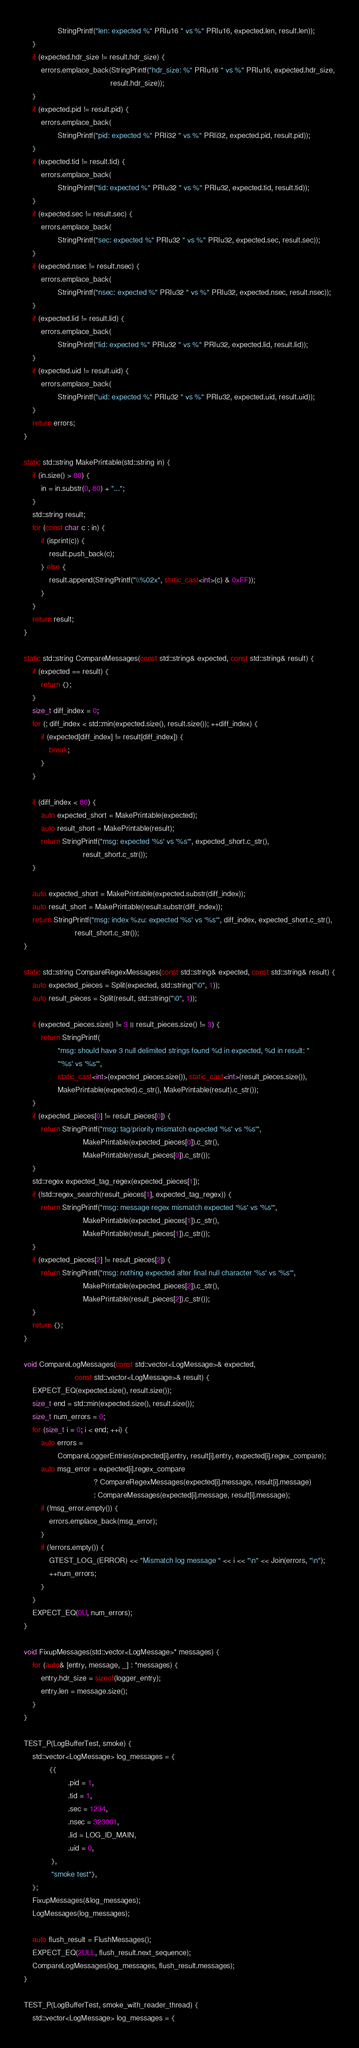<code> <loc_0><loc_0><loc_500><loc_500><_C++_>                StringPrintf("len: expected %" PRIu16 " vs %" PRIu16, expected.len, result.len));
    }
    if (expected.hdr_size != result.hdr_size) {
        errors.emplace_back(StringPrintf("hdr_size: %" PRIu16 " vs %" PRIu16, expected.hdr_size,
                                         result.hdr_size));
    }
    if (expected.pid != result.pid) {
        errors.emplace_back(
                StringPrintf("pid: expected %" PRIi32 " vs %" PRIi32, expected.pid, result.pid));
    }
    if (expected.tid != result.tid) {
        errors.emplace_back(
                StringPrintf("tid: expected %" PRIu32 " vs %" PRIu32, expected.tid, result.tid));
    }
    if (expected.sec != result.sec) {
        errors.emplace_back(
                StringPrintf("sec: expected %" PRIu32 " vs %" PRIu32, expected.sec, result.sec));
    }
    if (expected.nsec != result.nsec) {
        errors.emplace_back(
                StringPrintf("nsec: expected %" PRIu32 " vs %" PRIu32, expected.nsec, result.nsec));
    }
    if (expected.lid != result.lid) {
        errors.emplace_back(
                StringPrintf("lid: expected %" PRIu32 " vs %" PRIu32, expected.lid, result.lid));
    }
    if (expected.uid != result.uid) {
        errors.emplace_back(
                StringPrintf("uid: expected %" PRIu32 " vs %" PRIu32, expected.uid, result.uid));
    }
    return errors;
}

static std::string MakePrintable(std::string in) {
    if (in.size() > 80) {
        in = in.substr(0, 80) + "...";
    }
    std::string result;
    for (const char c : in) {
        if (isprint(c)) {
            result.push_back(c);
        } else {
            result.append(StringPrintf("\\%02x", static_cast<int>(c) & 0xFF));
        }
    }
    return result;
}

static std::string CompareMessages(const std::string& expected, const std::string& result) {
    if (expected == result) {
        return {};
    }
    size_t diff_index = 0;
    for (; diff_index < std::min(expected.size(), result.size()); ++diff_index) {
        if (expected[diff_index] != result[diff_index]) {
            break;
        }
    }

    if (diff_index < 80) {
        auto expected_short = MakePrintable(expected);
        auto result_short = MakePrintable(result);
        return StringPrintf("msg: expected '%s' vs '%s'", expected_short.c_str(),
                            result_short.c_str());
    }

    auto expected_short = MakePrintable(expected.substr(diff_index));
    auto result_short = MakePrintable(result.substr(diff_index));
    return StringPrintf("msg: index %zu: expected '%s' vs '%s'", diff_index, expected_short.c_str(),
                        result_short.c_str());
}

static std::string CompareRegexMessages(const std::string& expected, const std::string& result) {
    auto expected_pieces = Split(expected, std::string("\0", 1));
    auto result_pieces = Split(result, std::string("\0", 1));

    if (expected_pieces.size() != 3 || result_pieces.size() != 3) {
        return StringPrintf(
                "msg: should have 3 null delimited strings found %d in expected, %d in result: "
                "'%s' vs '%s'",
                static_cast<int>(expected_pieces.size()), static_cast<int>(result_pieces.size()),
                MakePrintable(expected).c_str(), MakePrintable(result).c_str());
    }
    if (expected_pieces[0] != result_pieces[0]) {
        return StringPrintf("msg: tag/priority mismatch expected '%s' vs '%s'",
                            MakePrintable(expected_pieces[0]).c_str(),
                            MakePrintable(result_pieces[0]).c_str());
    }
    std::regex expected_tag_regex(expected_pieces[1]);
    if (!std::regex_search(result_pieces[1], expected_tag_regex)) {
        return StringPrintf("msg: message regex mismatch expected '%s' vs '%s'",
                            MakePrintable(expected_pieces[1]).c_str(),
                            MakePrintable(result_pieces[1]).c_str());
    }
    if (expected_pieces[2] != result_pieces[2]) {
        return StringPrintf("msg: nothing expected after final null character '%s' vs '%s'",
                            MakePrintable(expected_pieces[2]).c_str(),
                            MakePrintable(result_pieces[2]).c_str());
    }
    return {};
}

void CompareLogMessages(const std::vector<LogMessage>& expected,
                        const std::vector<LogMessage>& result) {
    EXPECT_EQ(expected.size(), result.size());
    size_t end = std::min(expected.size(), result.size());
    size_t num_errors = 0;
    for (size_t i = 0; i < end; ++i) {
        auto errors =
                CompareLoggerEntries(expected[i].entry, result[i].entry, expected[i].regex_compare);
        auto msg_error = expected[i].regex_compare
                                 ? CompareRegexMessages(expected[i].message, result[i].message)
                                 : CompareMessages(expected[i].message, result[i].message);
        if (!msg_error.empty()) {
            errors.emplace_back(msg_error);
        }
        if (!errors.empty()) {
            GTEST_LOG_(ERROR) << "Mismatch log message " << i << "\n" << Join(errors, "\n");
            ++num_errors;
        }
    }
    EXPECT_EQ(0U, num_errors);
}

void FixupMessages(std::vector<LogMessage>* messages) {
    for (auto& [entry, message, _] : *messages) {
        entry.hdr_size = sizeof(logger_entry);
        entry.len = message.size();
    }
}

TEST_P(LogBufferTest, smoke) {
    std::vector<LogMessage> log_messages = {
            {{
                     .pid = 1,
                     .tid = 1,
                     .sec = 1234,
                     .nsec = 323001,
                     .lid = LOG_ID_MAIN,
                     .uid = 0,
             },
             "smoke test"},
    };
    FixupMessages(&log_messages);
    LogMessages(log_messages);

    auto flush_result = FlushMessages();
    EXPECT_EQ(2ULL, flush_result.next_sequence);
    CompareLogMessages(log_messages, flush_result.messages);
}

TEST_P(LogBufferTest, smoke_with_reader_thread) {
    std::vector<LogMessage> log_messages = {</code> 